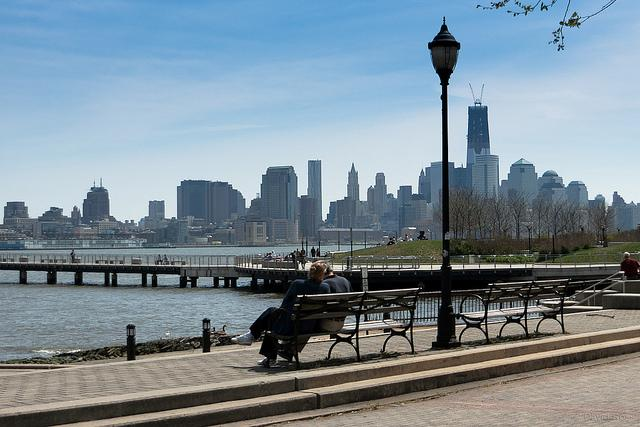Who is this area designed for? Please explain your reasoning. public. This area consists of a body of water, a sidewalk, and a paved area with benches, and there aren't any signs designating the area for specific people. 